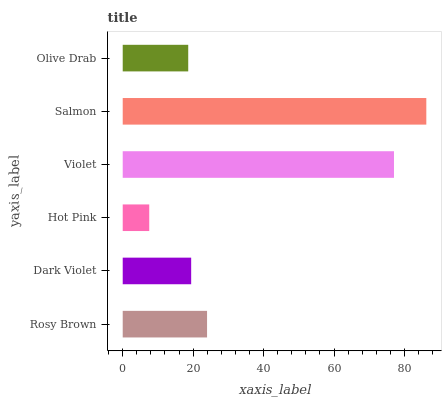Is Hot Pink the minimum?
Answer yes or no. Yes. Is Salmon the maximum?
Answer yes or no. Yes. Is Dark Violet the minimum?
Answer yes or no. No. Is Dark Violet the maximum?
Answer yes or no. No. Is Rosy Brown greater than Dark Violet?
Answer yes or no. Yes. Is Dark Violet less than Rosy Brown?
Answer yes or no. Yes. Is Dark Violet greater than Rosy Brown?
Answer yes or no. No. Is Rosy Brown less than Dark Violet?
Answer yes or no. No. Is Rosy Brown the high median?
Answer yes or no. Yes. Is Dark Violet the low median?
Answer yes or no. Yes. Is Dark Violet the high median?
Answer yes or no. No. Is Hot Pink the low median?
Answer yes or no. No. 